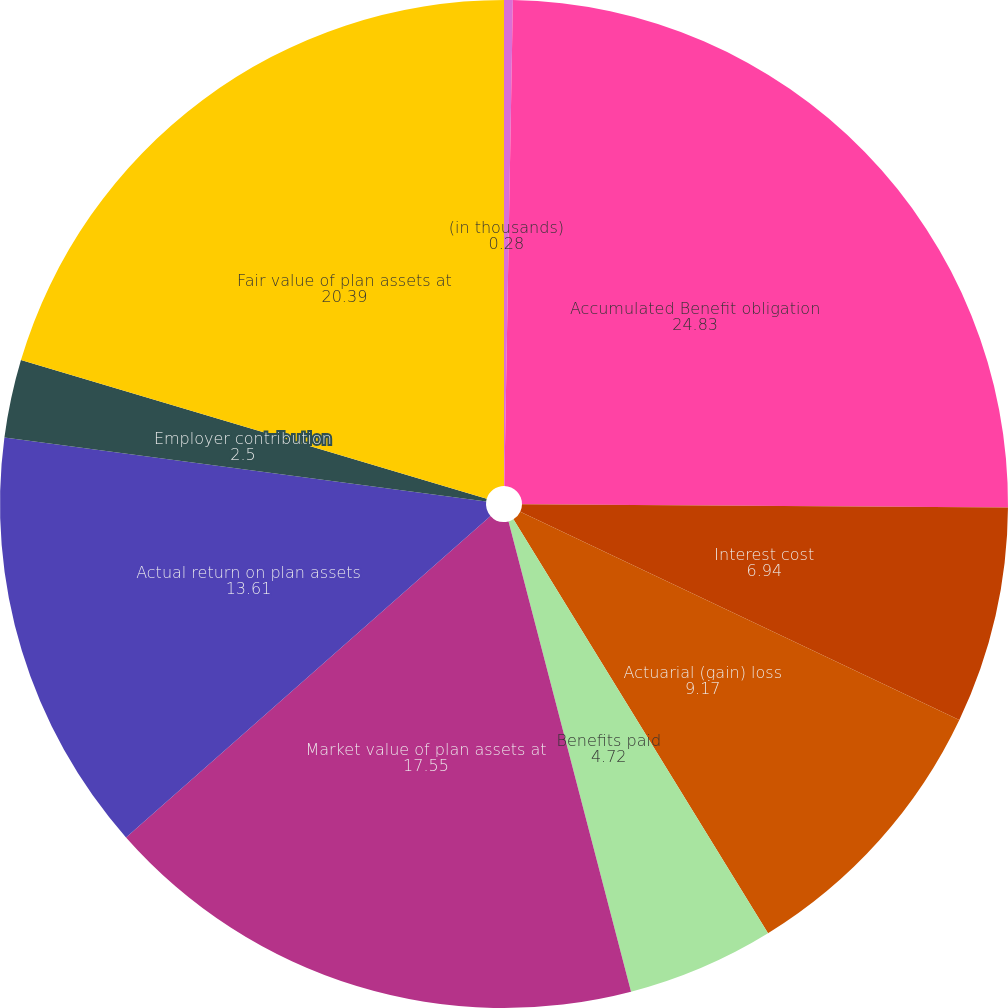<chart> <loc_0><loc_0><loc_500><loc_500><pie_chart><fcel>(in thousands)<fcel>Accumulated Benefit obligation<fcel>Interest cost<fcel>Actuarial (gain) loss<fcel>Benefits paid<fcel>Market value of plan assets at<fcel>Actual return on plan assets<fcel>Employer contribution<fcel>Fair value of plan assets at<nl><fcel>0.28%<fcel>24.83%<fcel>6.94%<fcel>9.17%<fcel>4.72%<fcel>17.55%<fcel>13.61%<fcel>2.5%<fcel>20.39%<nl></chart> 